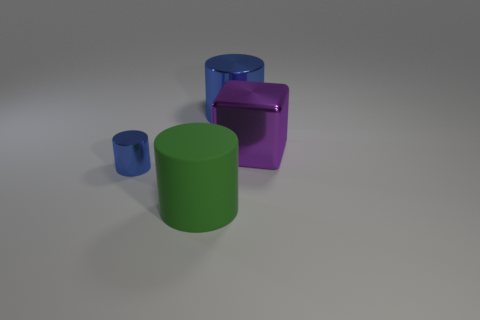Subtract all big metallic cylinders. How many cylinders are left? 2 Subtract all red balls. How many blue cylinders are left? 2 Add 4 tiny blue cylinders. How many objects exist? 8 Subtract all green cylinders. How many cylinders are left? 2 Subtract all cubes. How many objects are left? 3 Subtract 3 cylinders. How many cylinders are left? 0 Subtract all purple cylinders. Subtract all blue blocks. How many cylinders are left? 3 Subtract all big purple things. Subtract all big purple objects. How many objects are left? 2 Add 3 green cylinders. How many green cylinders are left? 4 Add 2 red matte cylinders. How many red matte cylinders exist? 2 